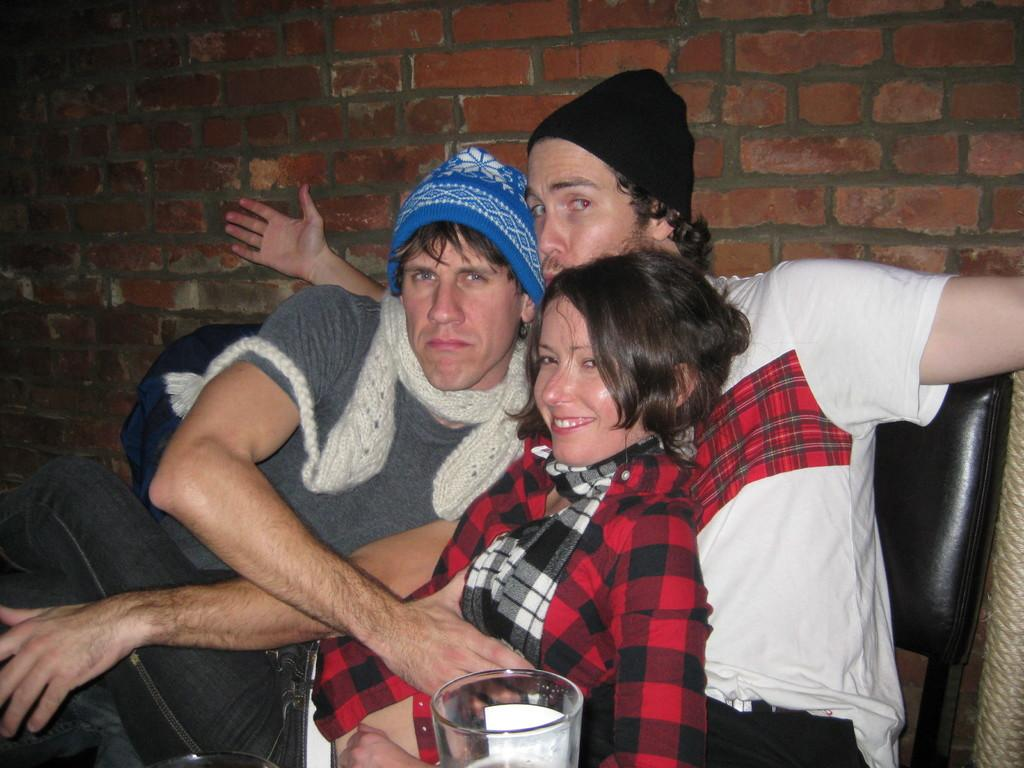How many people are in the image? There is a group of persons in the image. What are the persons in the image doing? The persons are sitting and smiling. What object is visible in the front of the image? There is a glass in the front of the image. What color is the wall in the background of the image? There is a red wall in the background of the image. What type of knowledge can be seen in the image? There is no indication of knowledge being present in the image; it features a group of persons sitting and smiling. How many teeth can be seen in the image? There is no person's mouth visible in the image, so it is not possible to determine the number of teeth. 